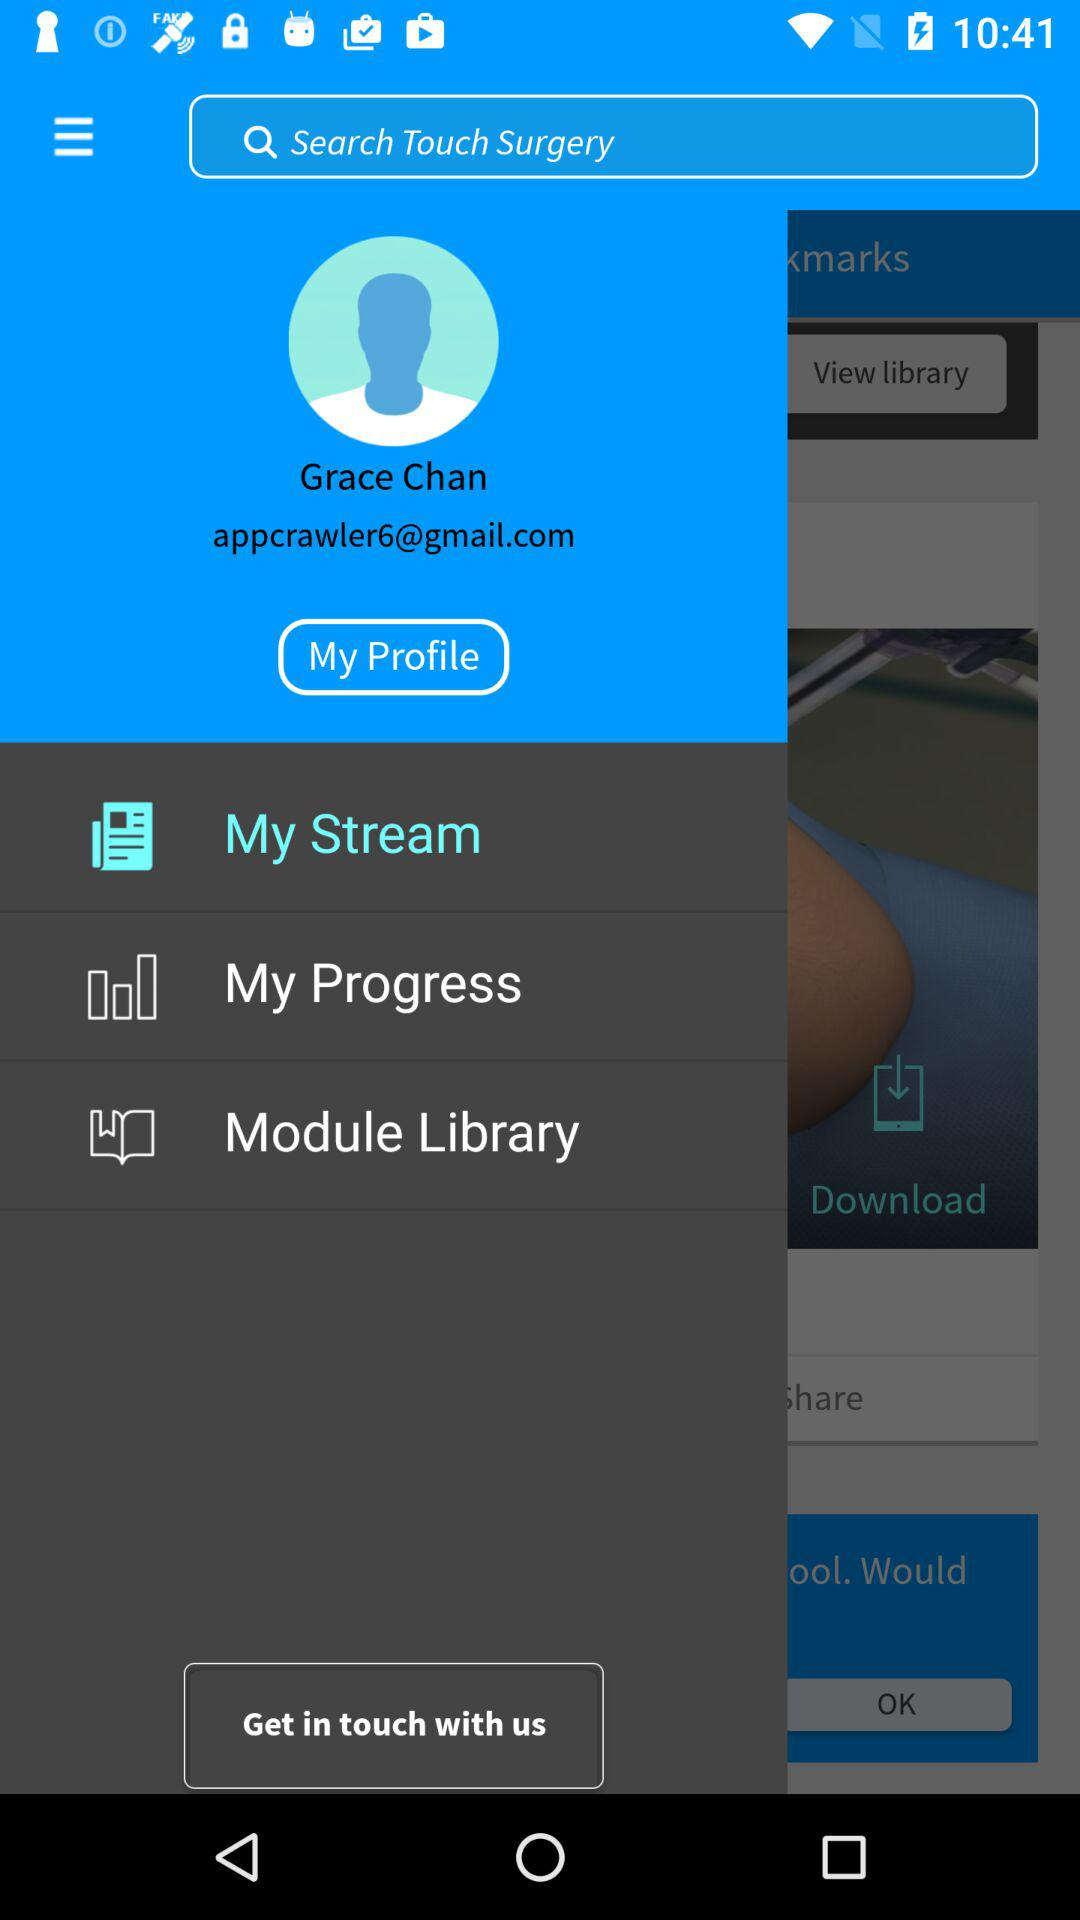What is the email address? The email address is appcrawler6@gmail.com. 